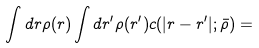<formula> <loc_0><loc_0><loc_500><loc_500>\int d { r } \rho ( { r } ) \int d { r } ^ { \prime } \rho ( { r } ^ { \prime } ) c ( | { r } - { r } ^ { \prime } | ; \bar { \rho } ) =</formula> 